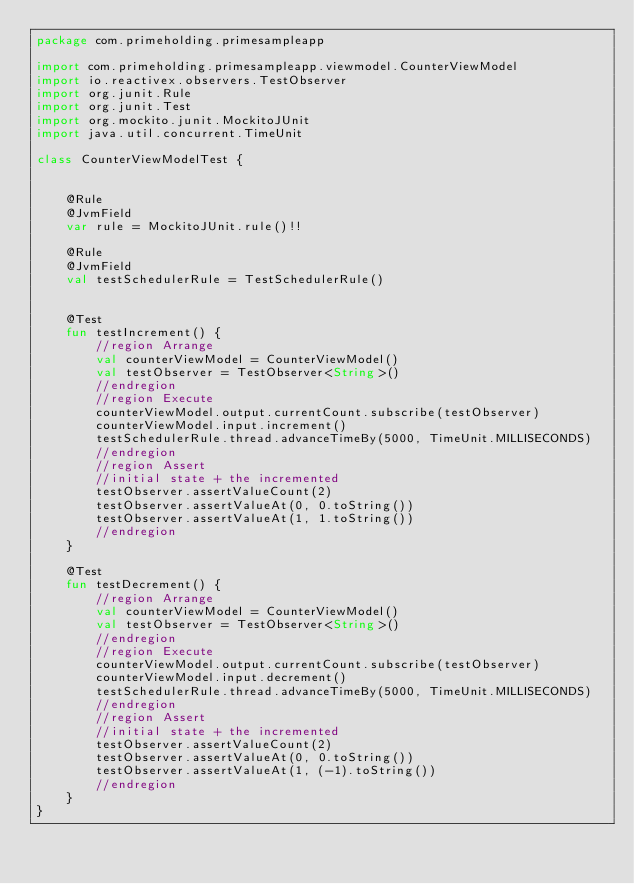Convert code to text. <code><loc_0><loc_0><loc_500><loc_500><_Kotlin_>package com.primeholding.primesampleapp

import com.primeholding.primesampleapp.viewmodel.CounterViewModel
import io.reactivex.observers.TestObserver
import org.junit.Rule
import org.junit.Test
import org.mockito.junit.MockitoJUnit
import java.util.concurrent.TimeUnit

class CounterViewModelTest {


    @Rule
    @JvmField
    var rule = MockitoJUnit.rule()!!

    @Rule
    @JvmField
    val testSchedulerRule = TestSchedulerRule()


    @Test
    fun testIncrement() {
        //region Arrange
        val counterViewModel = CounterViewModel()
        val testObserver = TestObserver<String>()
        //endregion
        //region Execute
        counterViewModel.output.currentCount.subscribe(testObserver)
        counterViewModel.input.increment()
        testSchedulerRule.thread.advanceTimeBy(5000, TimeUnit.MILLISECONDS)
        //endregion
        //region Assert
        //initial state + the incremented
        testObserver.assertValueCount(2)
        testObserver.assertValueAt(0, 0.toString())
        testObserver.assertValueAt(1, 1.toString())
        //endregion
    }

    @Test
    fun testDecrement() {
        //region Arrange
        val counterViewModel = CounterViewModel()
        val testObserver = TestObserver<String>()
        //endregion
        //region Execute
        counterViewModel.output.currentCount.subscribe(testObserver)
        counterViewModel.input.decrement()
        testSchedulerRule.thread.advanceTimeBy(5000, TimeUnit.MILLISECONDS)
        //endregion
        //region Assert
        //initial state + the incremented
        testObserver.assertValueCount(2)
        testObserver.assertValueAt(0, 0.toString())
        testObserver.assertValueAt(1, (-1).toString())
        //endregion
    }
}</code> 